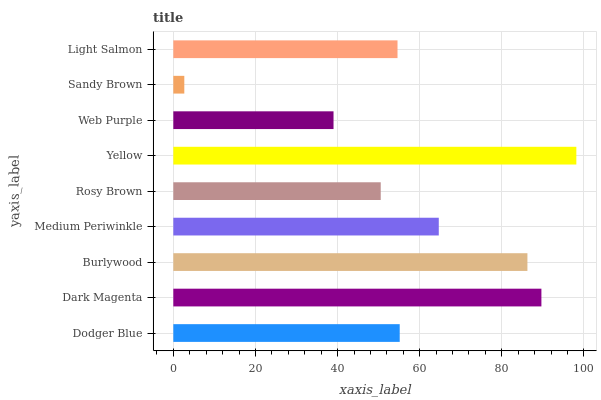Is Sandy Brown the minimum?
Answer yes or no. Yes. Is Yellow the maximum?
Answer yes or no. Yes. Is Dark Magenta the minimum?
Answer yes or no. No. Is Dark Magenta the maximum?
Answer yes or no. No. Is Dark Magenta greater than Dodger Blue?
Answer yes or no. Yes. Is Dodger Blue less than Dark Magenta?
Answer yes or no. Yes. Is Dodger Blue greater than Dark Magenta?
Answer yes or no. No. Is Dark Magenta less than Dodger Blue?
Answer yes or no. No. Is Dodger Blue the high median?
Answer yes or no. Yes. Is Dodger Blue the low median?
Answer yes or no. Yes. Is Web Purple the high median?
Answer yes or no. No. Is Sandy Brown the low median?
Answer yes or no. No. 